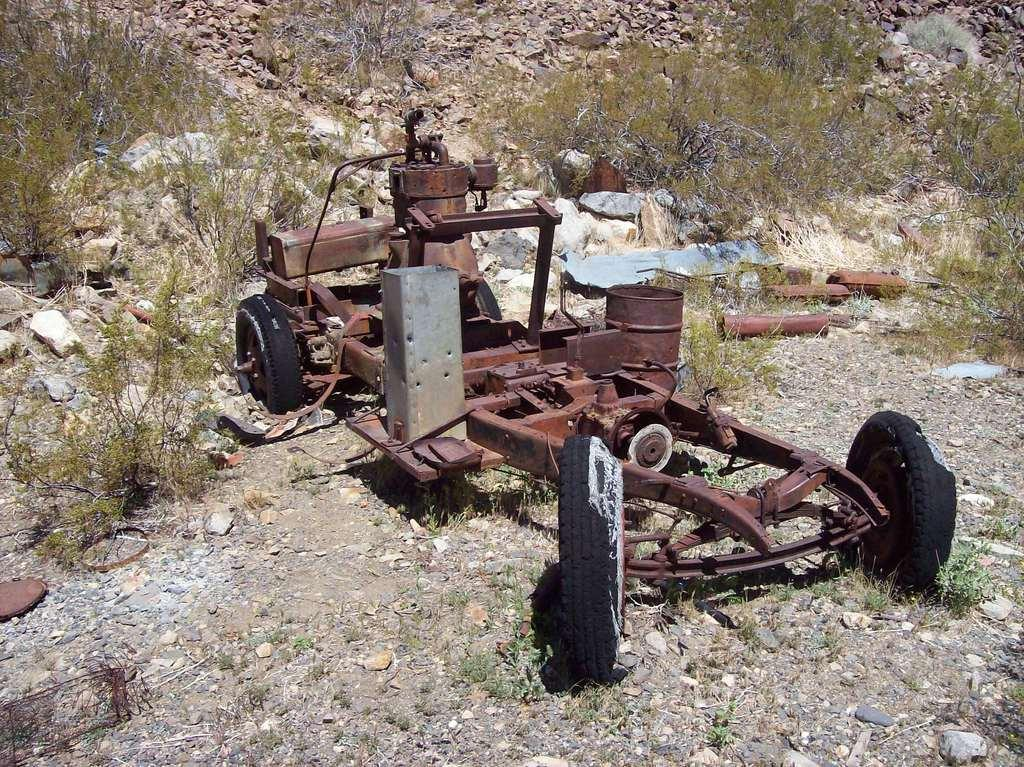What is the main subject in the center of the image? There is a vehicle and a drum in the center of the image. Can you describe the objects in the center of the image? There is a vehicle and a drum in the center of the image. What can be seen in the background of the image? There are rocks and trees in the background of the image. What is the surface on which the objects are placed? There is a ground at the bottom of the image. What type of liquid is being used for the treatment in the image? There is no treatment or liquid present in the image. Can you describe the haircut being given in the image? There is no haircut or person getting a haircut present in the image. 